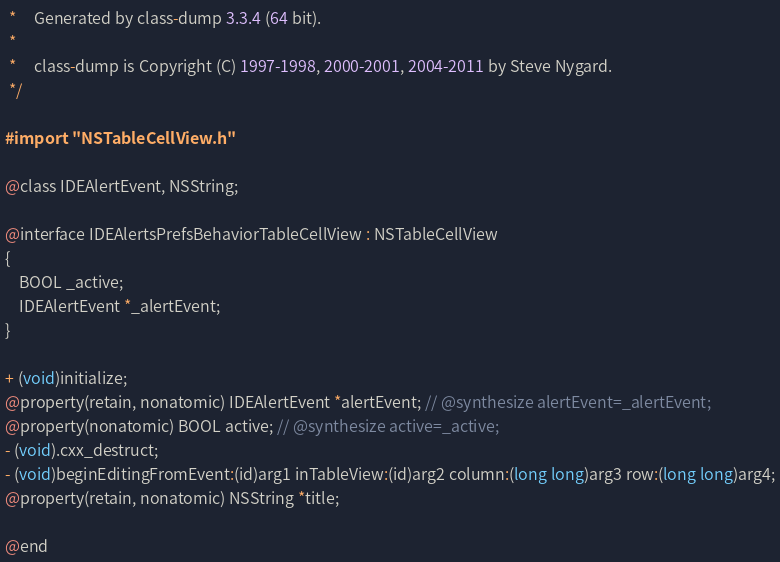<code> <loc_0><loc_0><loc_500><loc_500><_C_> *     Generated by class-dump 3.3.4 (64 bit).
 *
 *     class-dump is Copyright (C) 1997-1998, 2000-2001, 2004-2011 by Steve Nygard.
 */

#import "NSTableCellView.h"

@class IDEAlertEvent, NSString;

@interface IDEAlertsPrefsBehaviorTableCellView : NSTableCellView
{
    BOOL _active;
    IDEAlertEvent *_alertEvent;
}

+ (void)initialize;
@property(retain, nonatomic) IDEAlertEvent *alertEvent; // @synthesize alertEvent=_alertEvent;
@property(nonatomic) BOOL active; // @synthesize active=_active;
- (void).cxx_destruct;
- (void)beginEditingFromEvent:(id)arg1 inTableView:(id)arg2 column:(long long)arg3 row:(long long)arg4;
@property(retain, nonatomic) NSString *title;

@end

</code> 